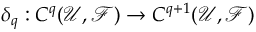<formula> <loc_0><loc_0><loc_500><loc_500>\delta _ { q } \colon C ^ { q } ( { \mathcal { U } } , { \mathcal { F } } ) \to C ^ { q + 1 } ( { \mathcal { U } } , { \mathcal { F } } )</formula> 